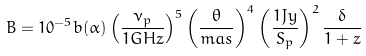Convert formula to latex. <formula><loc_0><loc_0><loc_500><loc_500>B = 1 0 ^ { - 5 } b ( \alpha ) \left ( \frac { \nu _ { p } } { 1 G H z } \right ) ^ { 5 } \left ( \frac { \theta } { m a s } \right ) ^ { 4 } \left ( \frac { 1 J y } { S _ { p } } \right ) ^ { 2 } \frac { \delta } { 1 + z }</formula> 